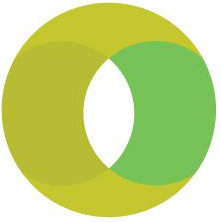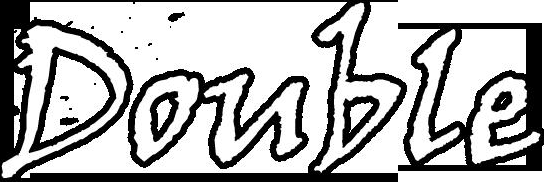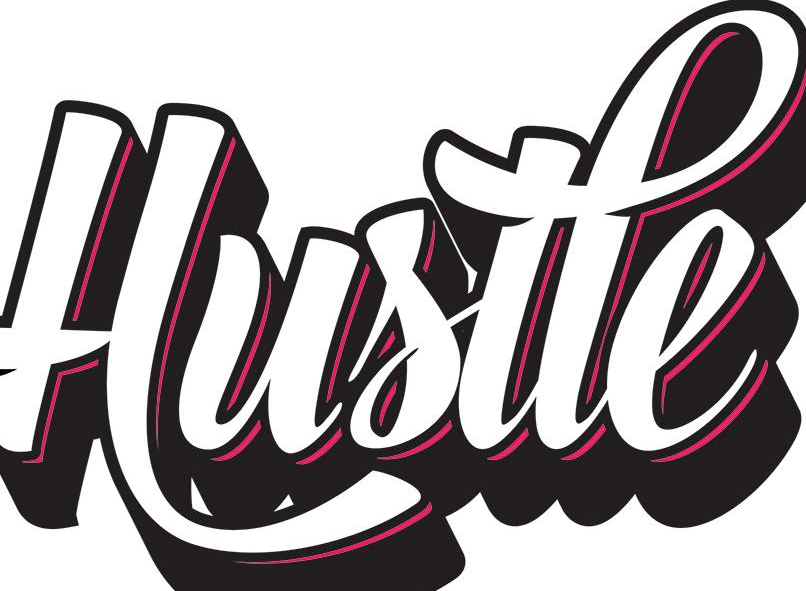Read the text content from these images in order, separated by a semicolon. O; Double; Hustle 